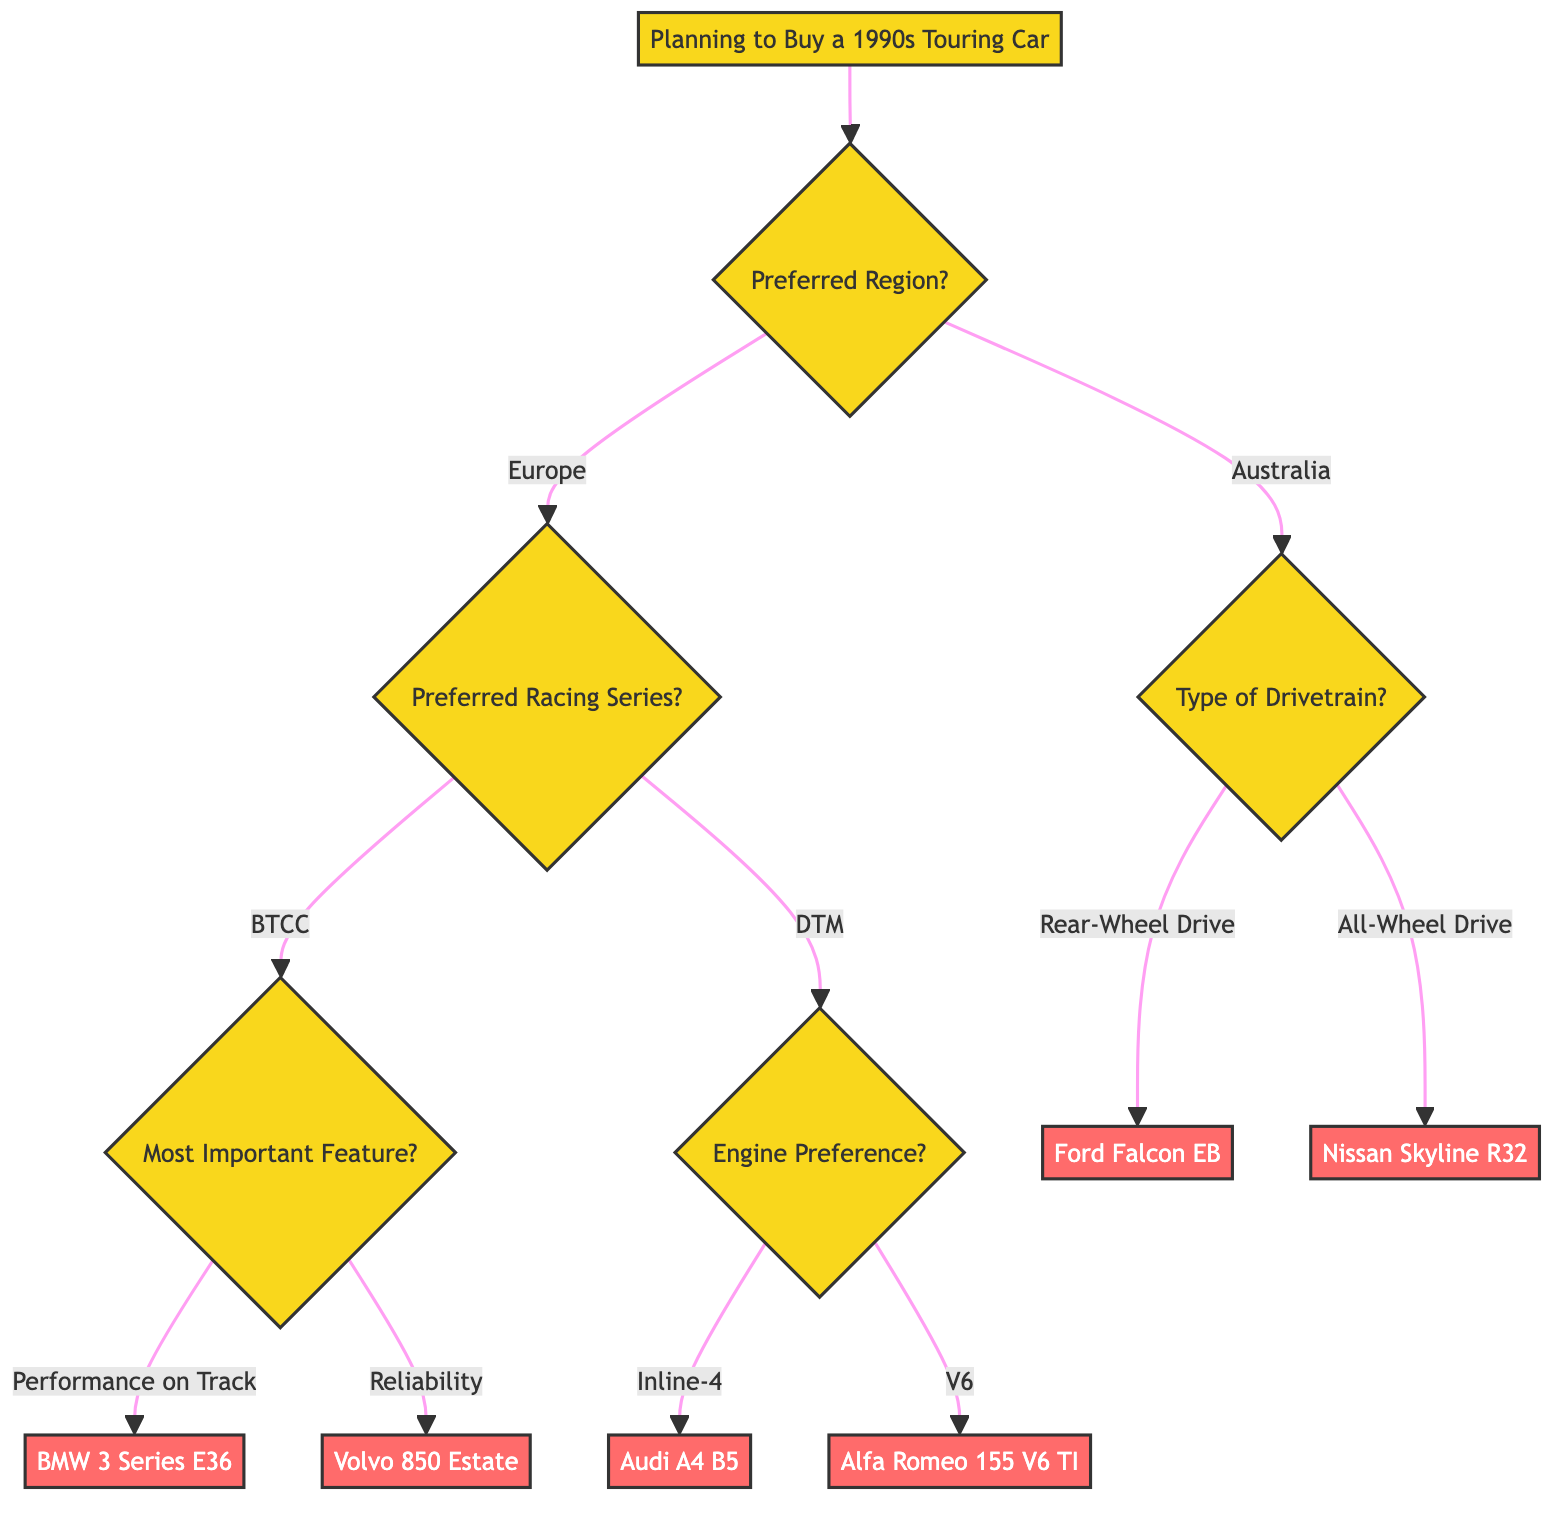What is the root question of the decision tree? The root question, which represents the starting point of the decision-making process, is "Planning to Buy a 1990s Touring Car".
Answer: Planning to Buy a 1990s Touring Car How many main branches are there from the root? From the root, there are two main branches: "Preferred Region?" leading to options for Europe and Australia.
Answer: 2 What are the two options for the "Preferred Region"? The diagram indicates two options branching from "Preferred Region": Europe and Australia.
Answer: Europe, Australia If "Preferred Region" is set to "Europe" and "Preferred Racing Series" is "BTCC", which car is recommended for "Reliability"? Traversing through "Preferred Region" as Europe and then selecting "BTCC" for "Preferred Racing Series", if "Most Important Feature for You?" is "Reliability", the recommended car is "Volvo 850 Estate".
Answer: Volvo 850 Estate Which car would you get if you choose "All-Wheel Drive" in Australia? If you select the "Australia" branch and then choose "All-Wheel Drive" under "Type of Drivetrain," the decision is "Nissan Skyline R32".
Answer: Nissan Skyline R32 What is the decision if the "Engine Preference" is "V6" under the "DTM" series? Under the "DTM" series, if "Engine Preference" is set to "V6," the resulting decision is "Alfa Romeo 155 V6 TI".
Answer: Alfa Romeo 155 V6 TI In the decision tree, which features lead to a recommendation of "BMW 3 Series E36"? The recommendation for "BMW 3 Series E36" is reached by beginning at "Europe", moving to "BTCC", and then selecting "Performance on Track" under "Most Important Feature for You".
Answer: BMW 3 Series E36 How are the options for drivetrain categorized under "Australia"? The options categorized under "Australia" for "Type of Drivetrain" include "Rear-Wheel Drive" and "All-Wheel Drive".
Answer: Rear-Wheel Drive, All-Wheel Drive What feature preference leads to the "Audi A4 B5" recommendation? The recommendation for "Audi A4 B5" stems from selecting "Europe", then "DTM" for the "Preferred Racing Series", and finally choosing "Inline-4" for "Engine Preference".
Answer: Audi A4 B5 